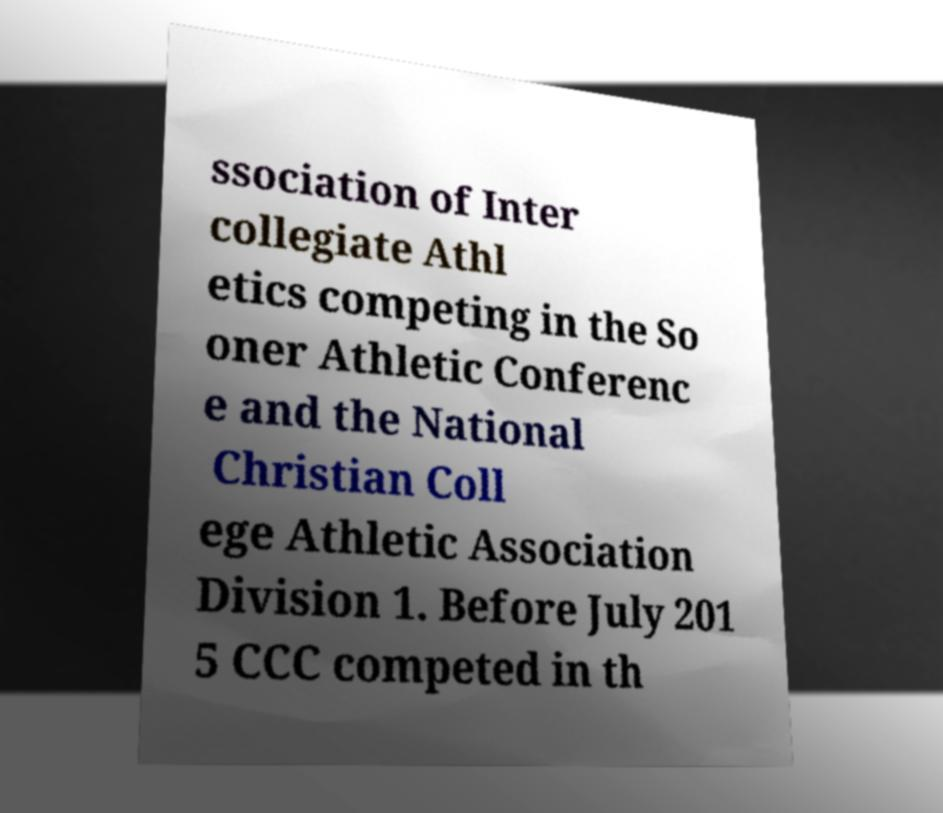Please read and relay the text visible in this image. What does it say? ssociation of Inter collegiate Athl etics competing in the So oner Athletic Conferenc e and the National Christian Coll ege Athletic Association Division 1. Before July 201 5 CCC competed in th 